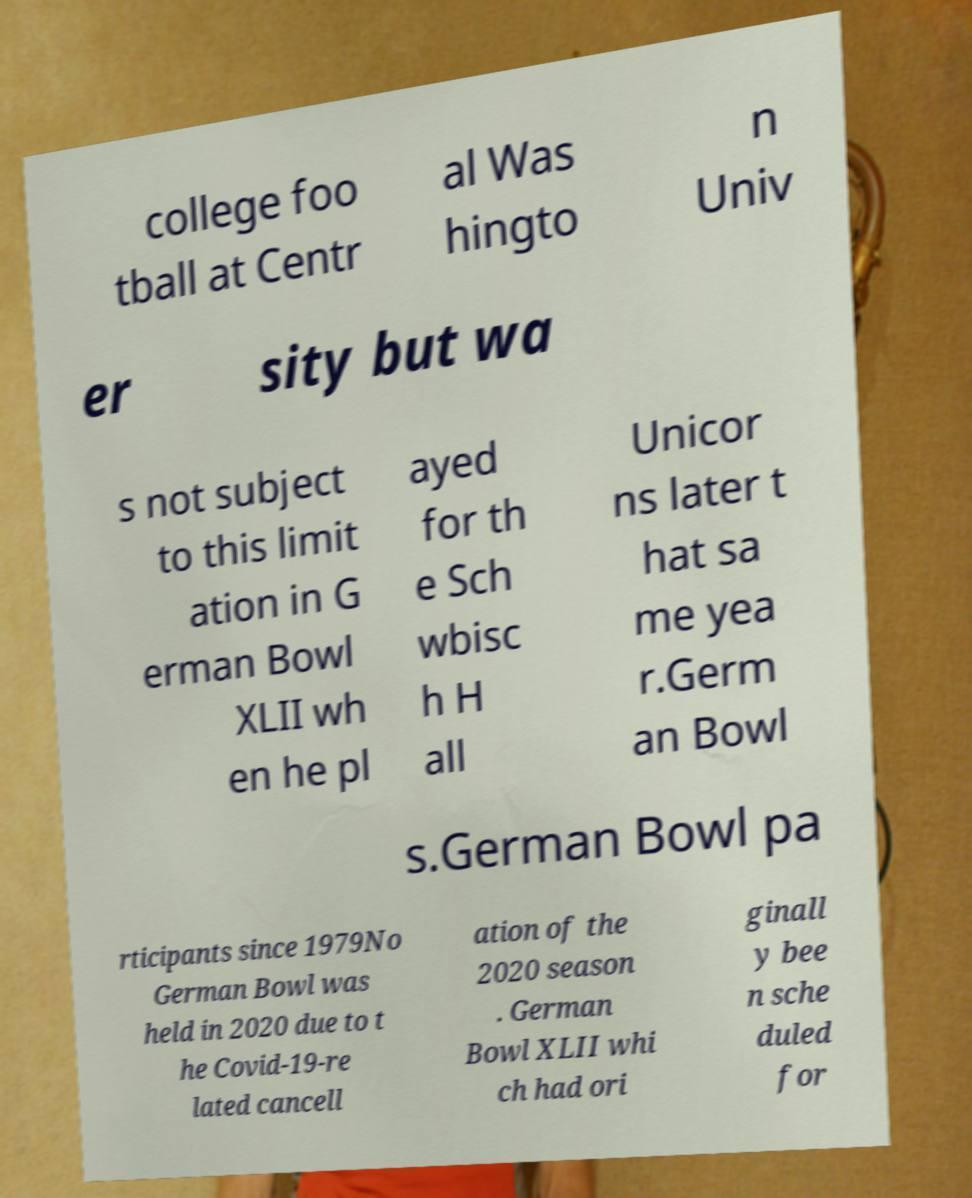Please read and relay the text visible in this image. What does it say? college foo tball at Centr al Was hingto n Univ er sity but wa s not subject to this limit ation in G erman Bowl XLII wh en he pl ayed for th e Sch wbisc h H all Unicor ns later t hat sa me yea r.Germ an Bowl s.German Bowl pa rticipants since 1979No German Bowl was held in 2020 due to t he Covid-19-re lated cancell ation of the 2020 season . German Bowl XLII whi ch had ori ginall y bee n sche duled for 